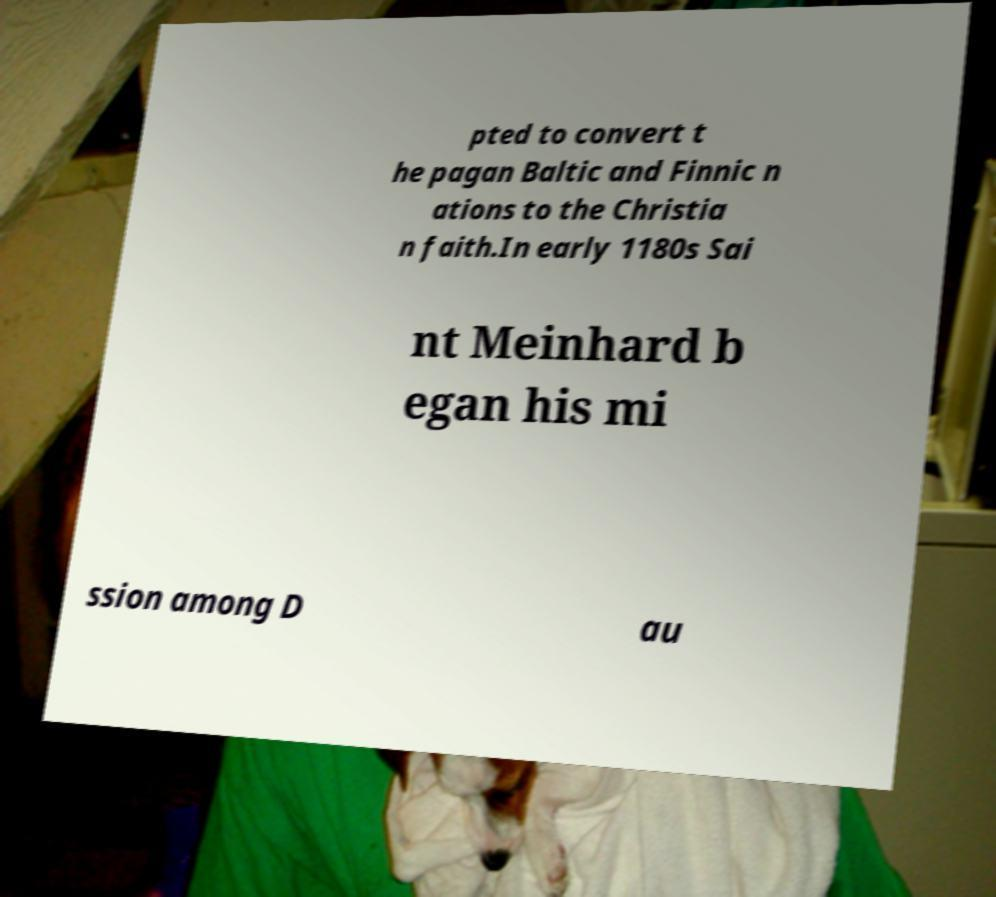Can you accurately transcribe the text from the provided image for me? pted to convert t he pagan Baltic and Finnic n ations to the Christia n faith.In early 1180s Sai nt Meinhard b egan his mi ssion among D au 